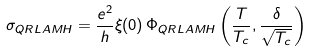<formula> <loc_0><loc_0><loc_500><loc_500>\sigma _ { Q R L A M H } = \frac { e ^ { 2 } } { h } \xi ( 0 ) \, \Phi _ { Q R L A M H } \left ( \frac { T } { T _ { c } } , \frac { \delta } { \sqrt { T _ { c } } } \right )</formula> 